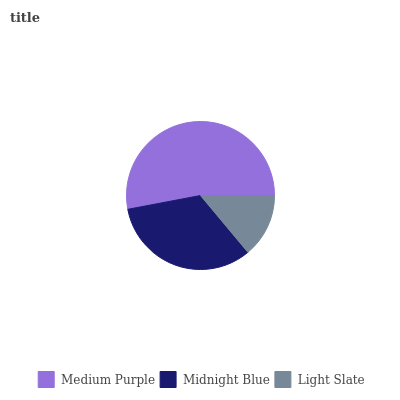Is Light Slate the minimum?
Answer yes or no. Yes. Is Medium Purple the maximum?
Answer yes or no. Yes. Is Midnight Blue the minimum?
Answer yes or no. No. Is Midnight Blue the maximum?
Answer yes or no. No. Is Medium Purple greater than Midnight Blue?
Answer yes or no. Yes. Is Midnight Blue less than Medium Purple?
Answer yes or no. Yes. Is Midnight Blue greater than Medium Purple?
Answer yes or no. No. Is Medium Purple less than Midnight Blue?
Answer yes or no. No. Is Midnight Blue the high median?
Answer yes or no. Yes. Is Midnight Blue the low median?
Answer yes or no. Yes. Is Medium Purple the high median?
Answer yes or no. No. Is Medium Purple the low median?
Answer yes or no. No. 